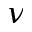<formula> <loc_0><loc_0><loc_500><loc_500>\nu</formula> 